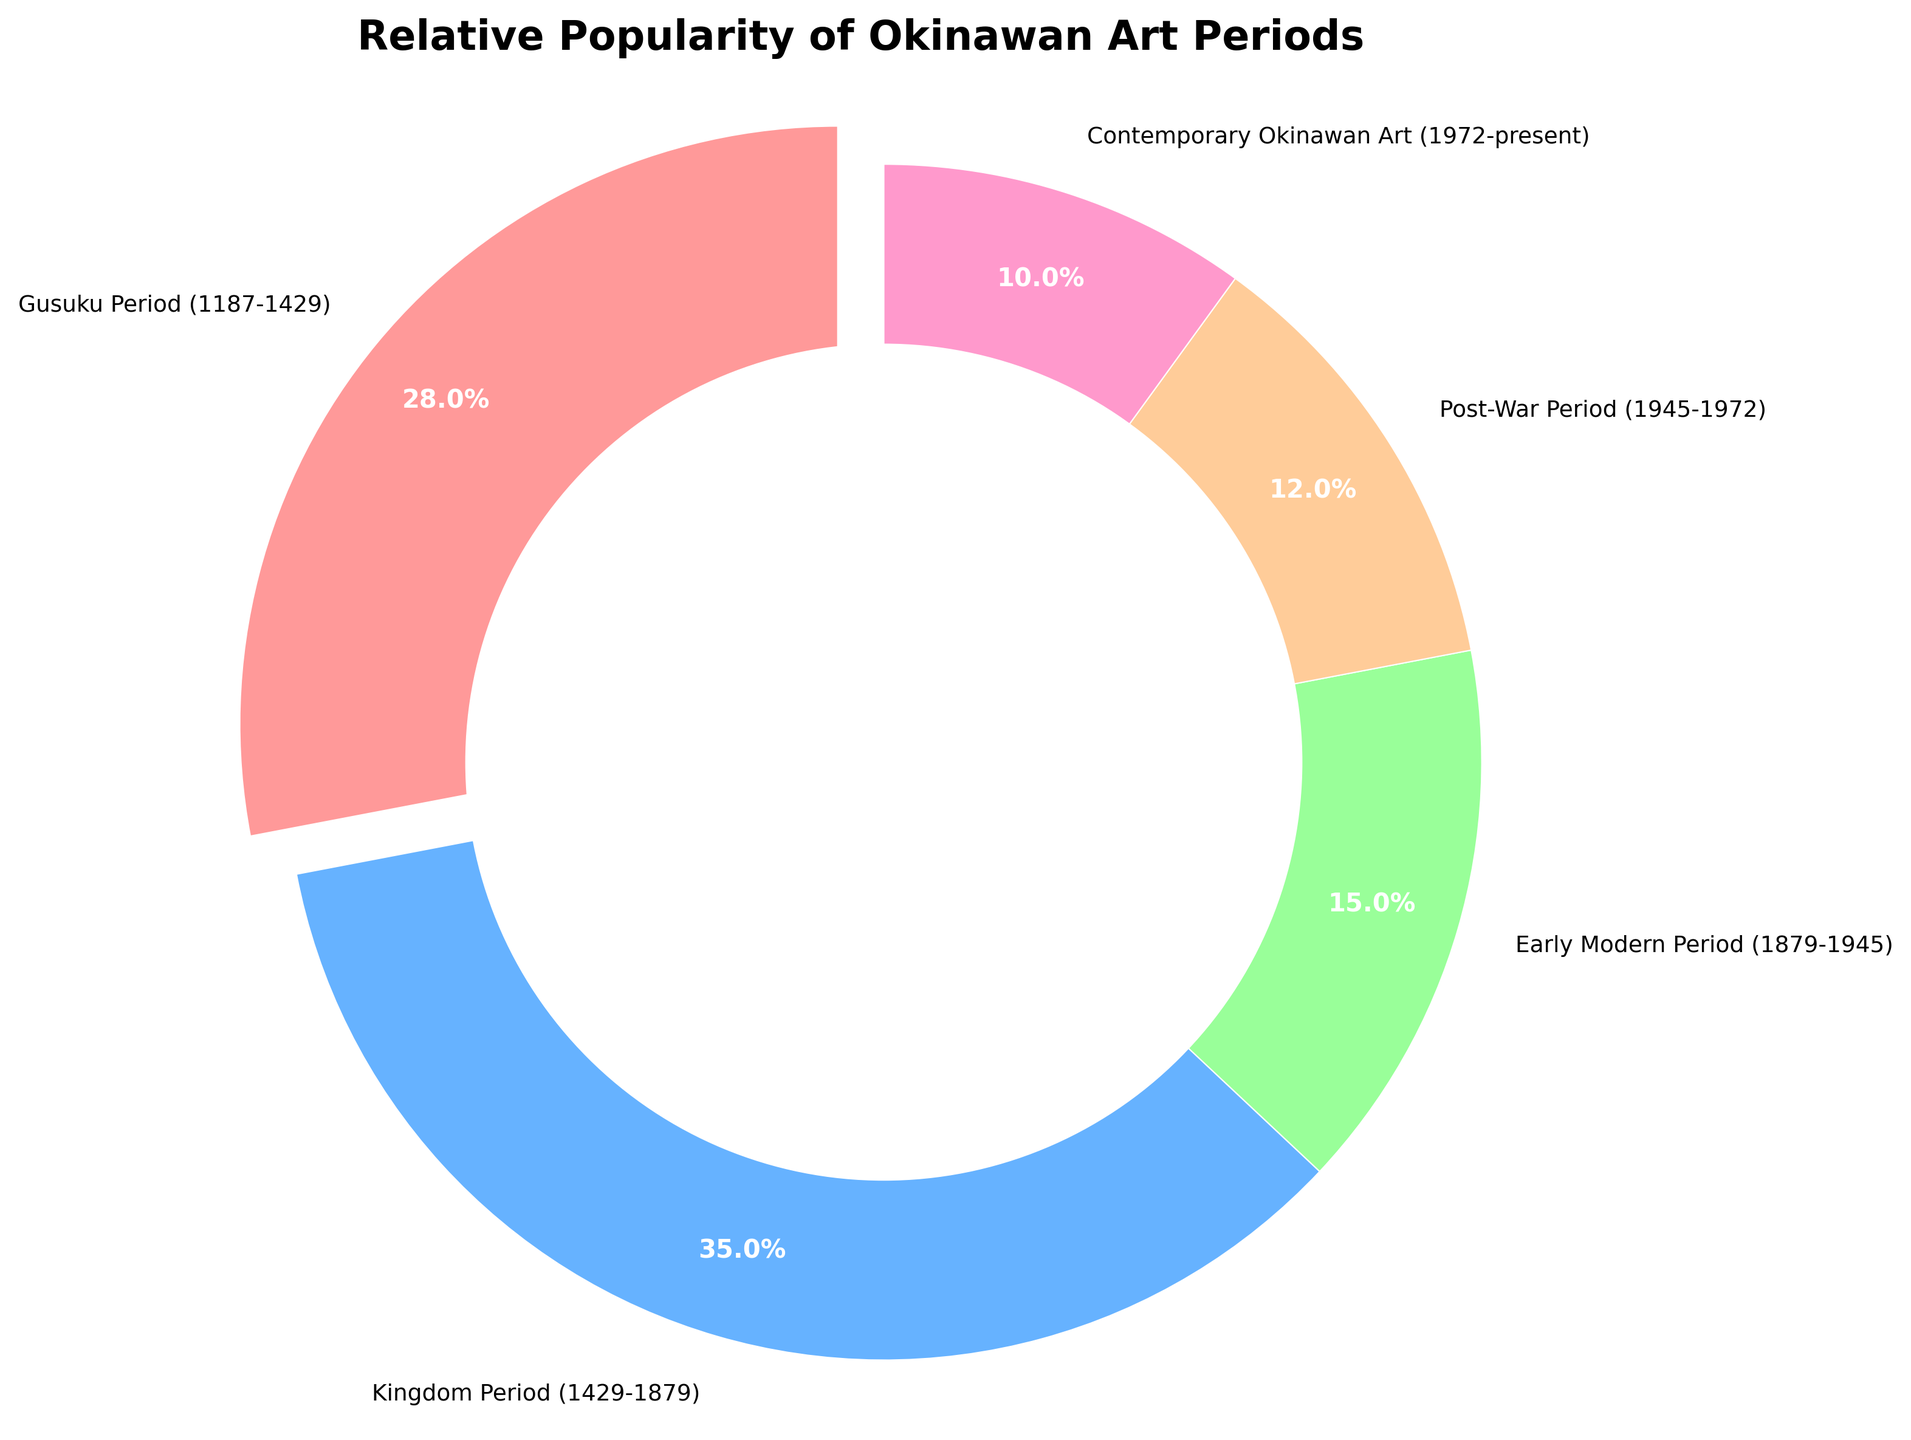What period has the highest access percentage? From the pie chart, the period with the largest wedge is the Kingdom Period.
Answer: Kingdom Period What is the combined access percentage of the Early Modern and Post-War Periods? According to the chart, the Early Modern Period has an access percentage of 15%, and the Post-War Period has 12%. Summing these percentages gives 15% + 12% = 27%.
Answer: 27% How much less popular is the Contemporary Okinawan Art period compared to the Kingdom Period? From the chart, the access percentage for Contemporary Okinawan Art is 10%, and for the Kingdom Period, it is 35%. The difference is 35% - 10% = 25%.
Answer: 25% Rank the art periods from most to least popular. By examining the sizes of the wedges in the pie chart, we can rank them as follows: Kingdom Period (35%), Gusuku Period (28%), Early Modern Period (15%), Post-War Period (12%), Contemporary Okinawan Art (10%).
Answer: Kingdom Period, Gusuku Period, Early Modern Period, Post-War Period, Contemporary Okinawan Art Which art periods have an access percentage more than 20%? From the chart, the periods with access percentages greater than 20% are the Kingdom Period (35%) and the Gusuku Period (28%).
Answer: Kingdom Period, Gusuku Period What color represents the Gusuku Period, and what is its significance? The Gusuku Period is represented by the color red (or the reddish-pink wedge), which indicates it has a 28% share of the total access percentage.
Answer: Red, 28% Which period has the lowest access percentage, and what is that value? The pie chart shows that Contemporary Okinawan Art has the smallest wedge, which corresponds to an access percentage of 10%.
Answer: Contemporary Okinawan Art, 10% What is the access percentage difference between the Kingdom Period and the Early Modern Period? The Kingdom Period has an access percentage of 35%, and the Early Modern Period has 15%. The difference can be calculated as 35% - 15% = 20%.
Answer: 20% 